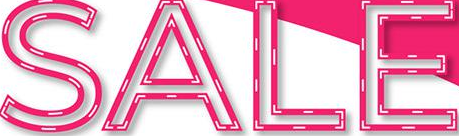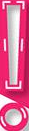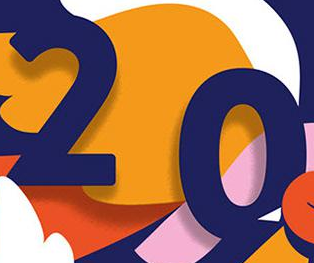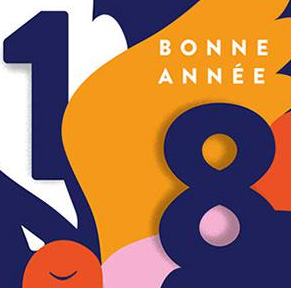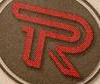What words can you see in these images in sequence, separated by a semicolon? SALE; !; 20; 18; R 